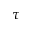<formula> <loc_0><loc_0><loc_500><loc_500>\tau</formula> 